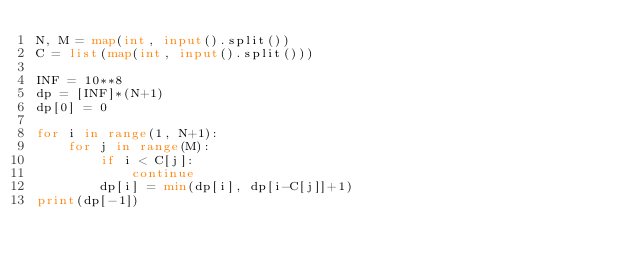Convert code to text. <code><loc_0><loc_0><loc_500><loc_500><_Python_>N, M = map(int, input().split())
C = list(map(int, input().split()))

INF = 10**8
dp = [INF]*(N+1)
dp[0] = 0

for i in range(1, N+1):
    for j in range(M):
        if i < C[j]:
            continue
        dp[i] = min(dp[i], dp[i-C[j]]+1)
print(dp[-1])

</code> 